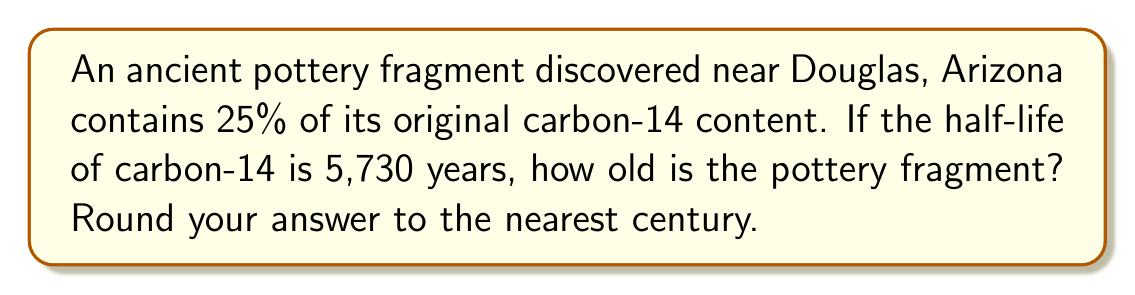Provide a solution to this math problem. To solve this problem, we'll use the exponential decay formula:

$$ A(t) = A_0 \cdot (1/2)^{t/t_{1/2}} $$

Where:
$A(t)$ = Amount remaining after time $t$
$A_0$ = Initial amount
$t$ = Time elapsed
$t_{1/2}$ = Half-life

We know:
$A(t)/A_0 = 25\% = 0.25$
$t_{1/2} = 5,730$ years

Step 1: Substitute the known values into the formula:
$$ 0.25 = (1/2)^{t/5730} $$

Step 2: Take the natural log of both sides:
$$ \ln(0.25) = \ln((1/2)^{t/5730}) $$

Step 3: Use the log property $\ln(a^b) = b\ln(a)$:
$$ \ln(0.25) = (t/5730) \cdot \ln(1/2) $$

Step 4: Solve for $t$:
$$ t = \frac{\ln(0.25) \cdot 5730}{\ln(1/2)} $$

Step 5: Calculate the result:
$$ t \approx 11,460 \text{ years} $$

Step 6: Round to the nearest century:
$11,460$ years rounds to $11,500$ years.
Answer: 11,500 years 